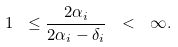<formula> <loc_0><loc_0><loc_500><loc_500>1 \ \leq \frac { 2 \alpha _ { i } } { 2 \alpha _ { i } - \delta _ { i } } \ < \ \infty .</formula> 